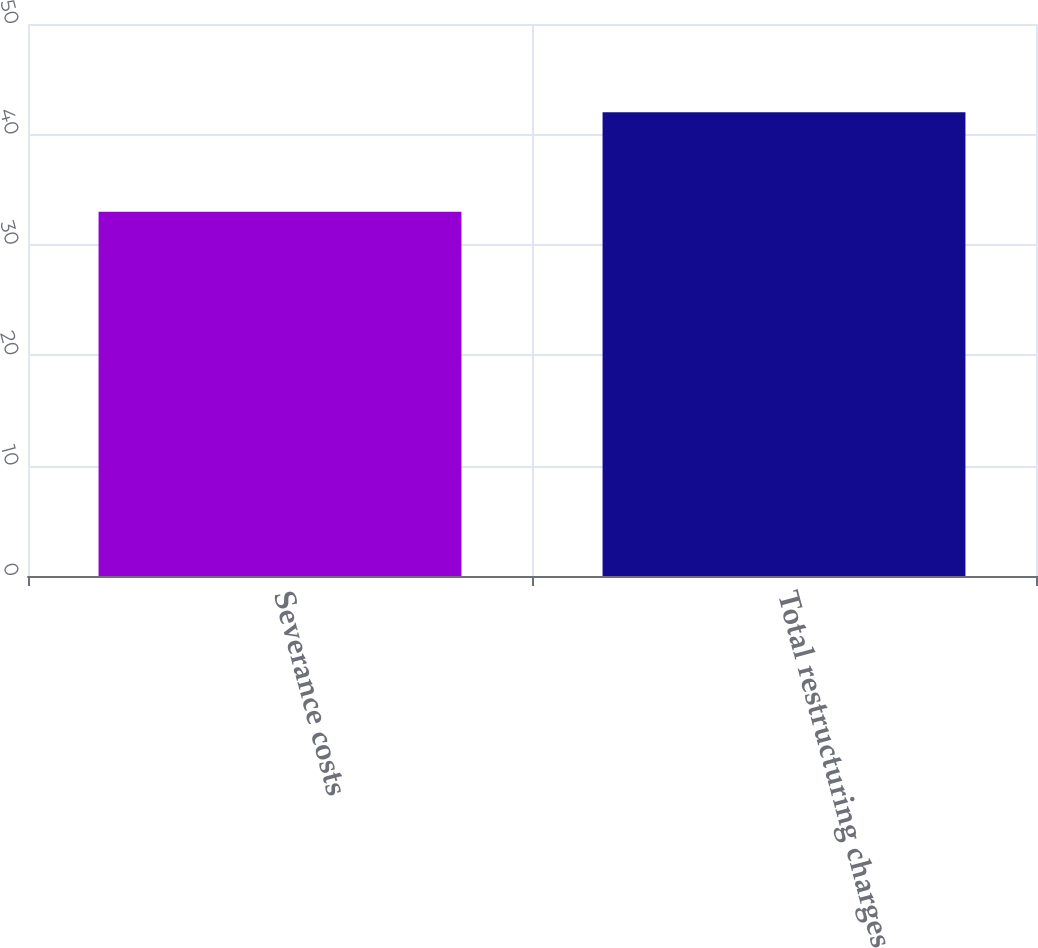Convert chart to OTSL. <chart><loc_0><loc_0><loc_500><loc_500><bar_chart><fcel>Severance costs<fcel>Total restructuring charges<nl><fcel>33<fcel>42<nl></chart> 